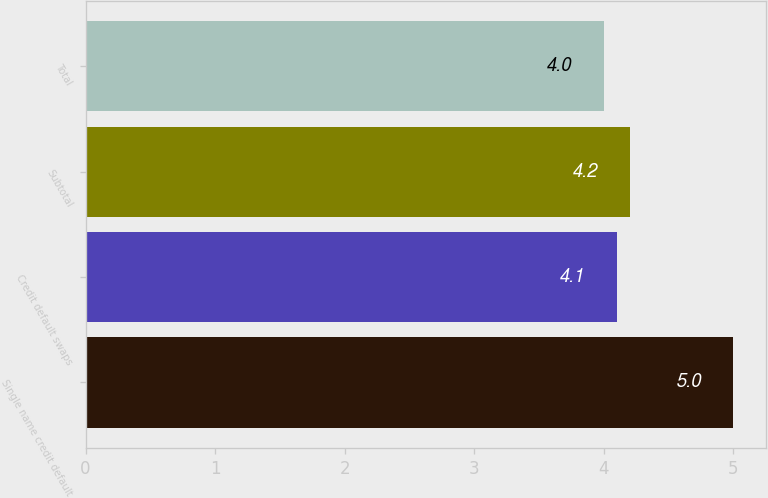Convert chart. <chart><loc_0><loc_0><loc_500><loc_500><bar_chart><fcel>Single name credit default<fcel>Credit default swaps<fcel>Subtotal<fcel>Total<nl><fcel>5<fcel>4.1<fcel>4.2<fcel>4<nl></chart> 